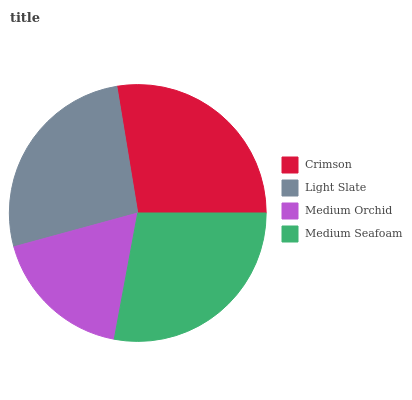Is Medium Orchid the minimum?
Answer yes or no. Yes. Is Medium Seafoam the maximum?
Answer yes or no. Yes. Is Light Slate the minimum?
Answer yes or no. No. Is Light Slate the maximum?
Answer yes or no. No. Is Crimson greater than Light Slate?
Answer yes or no. Yes. Is Light Slate less than Crimson?
Answer yes or no. Yes. Is Light Slate greater than Crimson?
Answer yes or no. No. Is Crimson less than Light Slate?
Answer yes or no. No. Is Crimson the high median?
Answer yes or no. Yes. Is Light Slate the low median?
Answer yes or no. Yes. Is Medium Seafoam the high median?
Answer yes or no. No. Is Medium Orchid the low median?
Answer yes or no. No. 